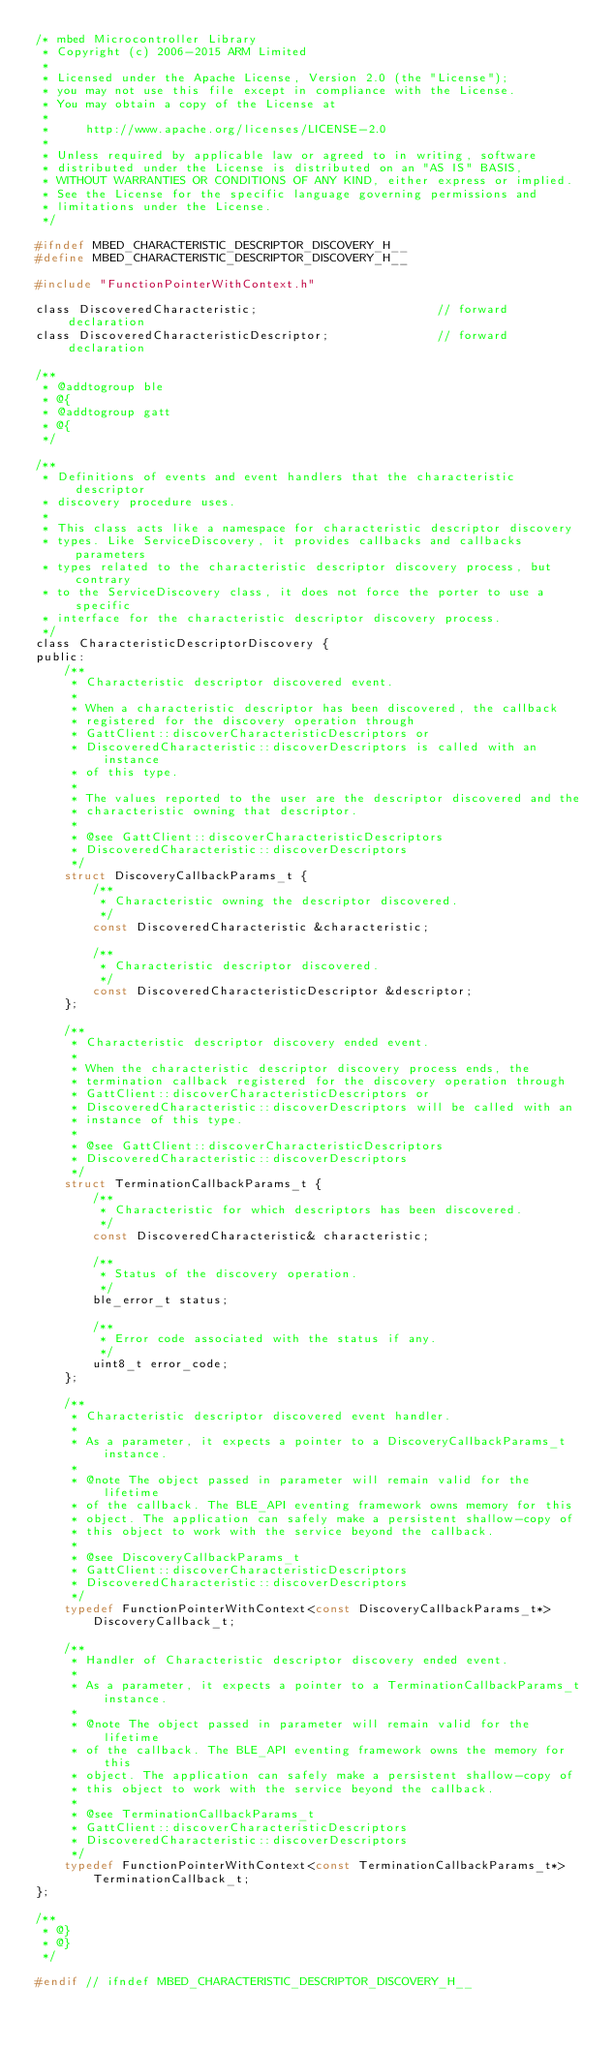Convert code to text. <code><loc_0><loc_0><loc_500><loc_500><_C_>/* mbed Microcontroller Library
 * Copyright (c) 2006-2015 ARM Limited
 *
 * Licensed under the Apache License, Version 2.0 (the "License");
 * you may not use this file except in compliance with the License.
 * You may obtain a copy of the License at
 *
 *     http://www.apache.org/licenses/LICENSE-2.0
 *
 * Unless required by applicable law or agreed to in writing, software
 * distributed under the License is distributed on an "AS IS" BASIS,
 * WITHOUT WARRANTIES OR CONDITIONS OF ANY KIND, either express or implied.
 * See the License for the specific language governing permissions and
 * limitations under the License.
 */

#ifndef MBED_CHARACTERISTIC_DESCRIPTOR_DISCOVERY_H__
#define MBED_CHARACTERISTIC_DESCRIPTOR_DISCOVERY_H__

#include "FunctionPointerWithContext.h"

class DiscoveredCharacteristic;                         // forward declaration
class DiscoveredCharacteristicDescriptor;               // forward declaration

/**
 * @addtogroup ble
 * @{
 * @addtogroup gatt
 * @{
 */

/**
 * Definitions of events and event handlers that the characteristic descriptor
 * discovery procedure uses.
 *
 * This class acts like a namespace for characteristic descriptor discovery
 * types. Like ServiceDiscovery, it provides callbacks and callbacks parameters
 * types related to the characteristic descriptor discovery process, but contrary
 * to the ServiceDiscovery class, it does not force the porter to use a specific
 * interface for the characteristic descriptor discovery process.
 */
class CharacteristicDescriptorDiscovery {
public:
    /**
     * Characteristic descriptor discovered event.
     *
     * When a characteristic descriptor has been discovered, the callback
     * registered for the discovery operation through
     * GattClient::discoverCharacteristicDescriptors or
     * DiscoveredCharacteristic::discoverDescriptors is called with an instance
     * of this type.
     *
     * The values reported to the user are the descriptor discovered and the
     * characteristic owning that descriptor.
     *
     * @see GattClient::discoverCharacteristicDescriptors
     * DiscoveredCharacteristic::discoverDescriptors
     */
    struct DiscoveryCallbackParams_t {
        /**
         * Characteristic owning the descriptor discovered.
         */
        const DiscoveredCharacteristic &characteristic;

        /**
         * Characteristic descriptor discovered.
         */
        const DiscoveredCharacteristicDescriptor &descriptor;
    };

    /**
     * Characteristic descriptor discovery ended event.
     *
     * When the characteristic descriptor discovery process ends, the
     * termination callback registered for the discovery operation through
     * GattClient::discoverCharacteristicDescriptors or
     * DiscoveredCharacteristic::discoverDescriptors will be called with an
     * instance of this type.
     *
     * @see GattClient::discoverCharacteristicDescriptors
     * DiscoveredCharacteristic::discoverDescriptors
     */
    struct TerminationCallbackParams_t {
        /**
         * Characteristic for which descriptors has been discovered.
         */
        const DiscoveredCharacteristic& characteristic;

        /**
         * Status of the discovery operation.
         */
        ble_error_t status;

        /**
         * Error code associated with the status if any.
         */
        uint8_t error_code;
    };

    /**
     * Characteristic descriptor discovered event handler.
     *
     * As a parameter, it expects a pointer to a DiscoveryCallbackParams_t instance.
     *
     * @note The object passed in parameter will remain valid for the lifetime
     * of the callback. The BLE_API eventing framework owns memory for this
     * object. The application can safely make a persistent shallow-copy of
     * this object to work with the service beyond the callback.
     *
     * @see DiscoveryCallbackParams_t
     * GattClient::discoverCharacteristicDescriptors
     * DiscoveredCharacteristic::discoverDescriptors
     */
    typedef FunctionPointerWithContext<const DiscoveryCallbackParams_t*>
        DiscoveryCallback_t;

    /**
     * Handler of Characteristic descriptor discovery ended event.
     *
     * As a parameter, it expects a pointer to a TerminationCallbackParams_t instance.
     *
     * @note The object passed in parameter will remain valid for the lifetime
     * of the callback. The BLE_API eventing framework owns the memory for this
     * object. The application can safely make a persistent shallow-copy of
     * this object to work with the service beyond the callback.
     *
     * @see TerminationCallbackParams_t
     * GattClient::discoverCharacteristicDescriptors
     * DiscoveredCharacteristic::discoverDescriptors
     */
    typedef FunctionPointerWithContext<const TerminationCallbackParams_t*>
        TerminationCallback_t;
};

/**
 * @}
 * @}
 */

#endif // ifndef MBED_CHARACTERISTIC_DESCRIPTOR_DISCOVERY_H__
</code> 